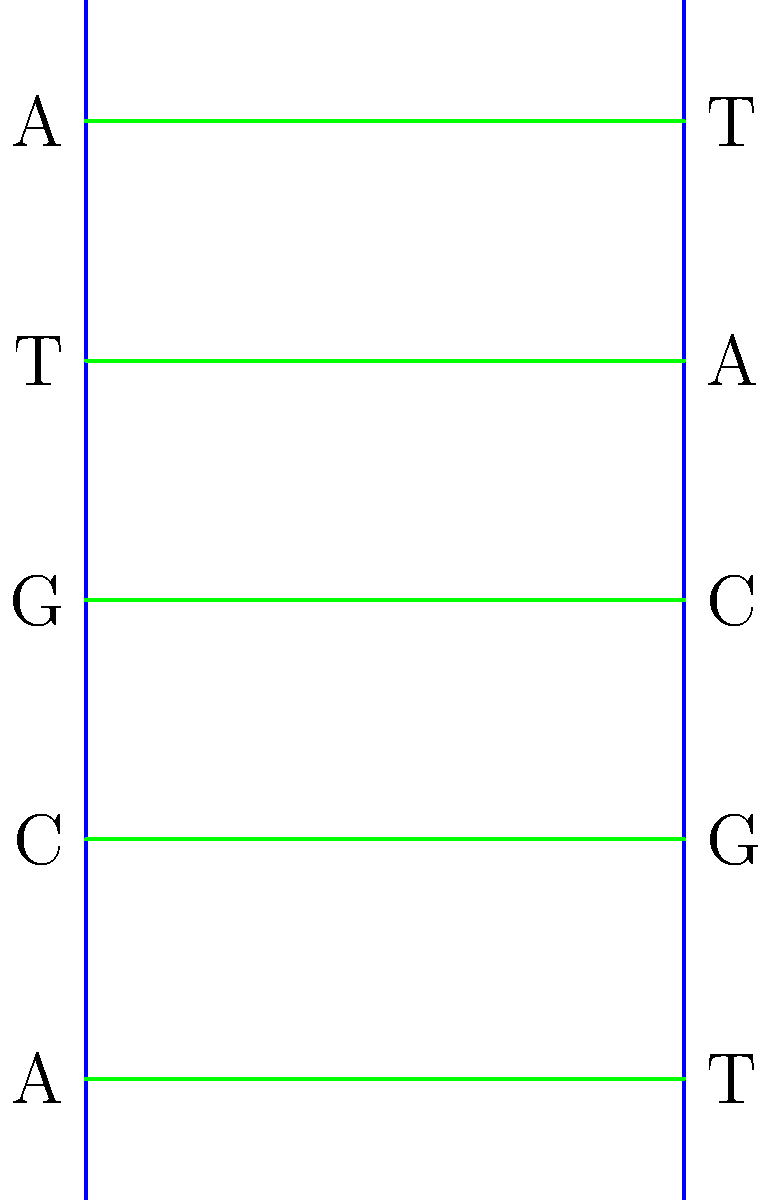In the simplified DNA structure shown above, which base pair is represented at the third rung from the bottom? To answer this question, we need to analyze the simplified DNA structure step-by-step:

1. Recall that DNA has a double-helix structure with two sugar-phosphate backbones (shown as blue vertical lines in the diagram) and base pairs connecting them.

2. The base pairs in DNA always follow specific pairing rules:
   - Adenine (A) pairs with Thymine (T)
   - Cytosine (C) pairs with Guanine (G)

3. Starting from the bottom of the diagram, we can identify the base pairs:
   - First rung: A-T
   - Second rung: C-G
   - Third rung: G-C
   - Fourth rung: T-A
   - Fifth rung: A-T

4. The question asks about the third rung from the bottom.

5. Looking at the third rung, we can see that it is labeled with G on the left side and C on the right side.

Therefore, the base pair represented at the third rung from the bottom is G-C (Guanine-Cytosine).
Answer: G-C (Guanine-Cytosine) 